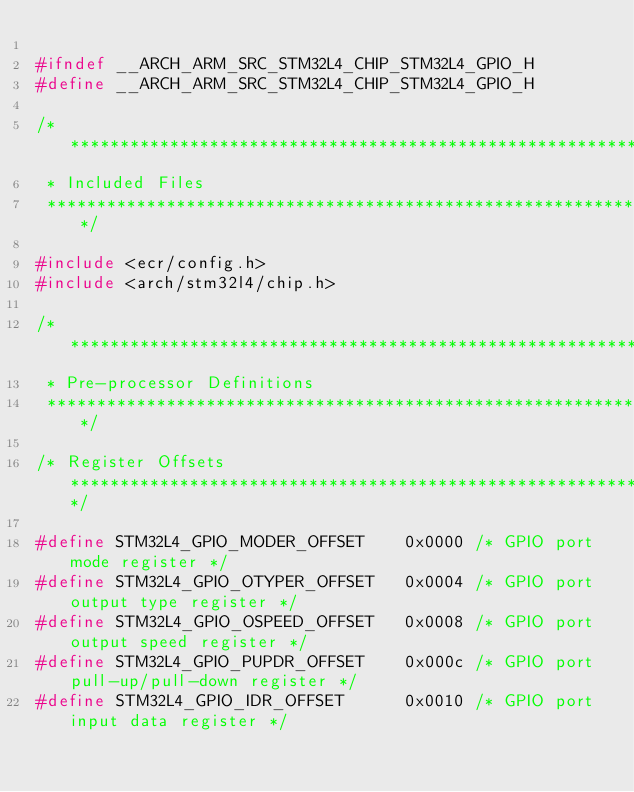<code> <loc_0><loc_0><loc_500><loc_500><_C_>
#ifndef __ARCH_ARM_SRC_STM32L4_CHIP_STM32L4_GPIO_H
#define __ARCH_ARM_SRC_STM32L4_CHIP_STM32L4_GPIO_H

/************************************************************************************
 * Included Files
 ************************************************************************************/

#include <ecr/config.h>
#include <arch/stm32l4/chip.h>

/************************************************************************************
 * Pre-processor Definitions
 ************************************************************************************/

/* Register Offsets *****************************************************************/

#define STM32L4_GPIO_MODER_OFFSET    0x0000 /* GPIO port mode register */
#define STM32L4_GPIO_OTYPER_OFFSET   0x0004 /* GPIO port output type register */
#define STM32L4_GPIO_OSPEED_OFFSET   0x0008 /* GPIO port output speed register */
#define STM32L4_GPIO_PUPDR_OFFSET    0x000c /* GPIO port pull-up/pull-down register */
#define STM32L4_GPIO_IDR_OFFSET      0x0010 /* GPIO port input data register */</code> 